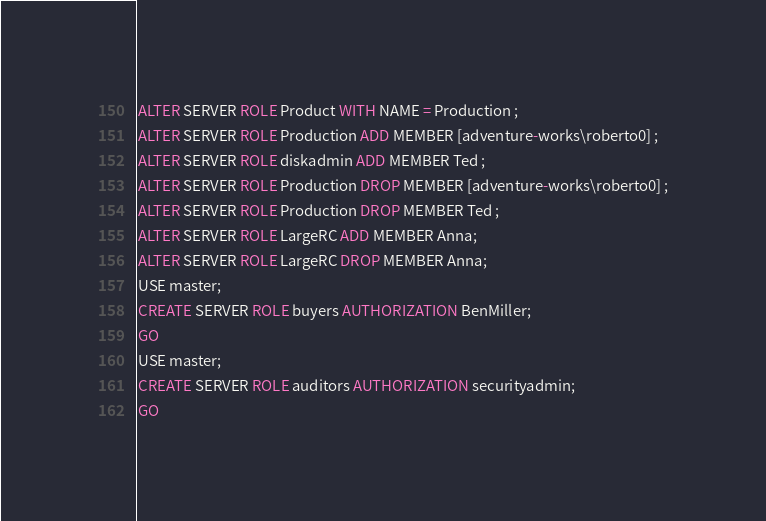Convert code to text. <code><loc_0><loc_0><loc_500><loc_500><_SQL_>ALTER SERVER ROLE Product WITH NAME = Production ;
ALTER SERVER ROLE Production ADD MEMBER [adventure-works\roberto0] ;
ALTER SERVER ROLE diskadmin ADD MEMBER Ted ;
ALTER SERVER ROLE Production DROP MEMBER [adventure-works\roberto0] ;
ALTER SERVER ROLE Production DROP MEMBER Ted ;
ALTER SERVER ROLE LargeRC ADD MEMBER Anna;
ALTER SERVER ROLE LargeRC DROP MEMBER Anna;
USE master;  
CREATE SERVER ROLE buyers AUTHORIZATION BenMiller;  
GO  
USE master;
CREATE SERVER ROLE auditors AUTHORIZATION securityadmin;
GO

</code> 